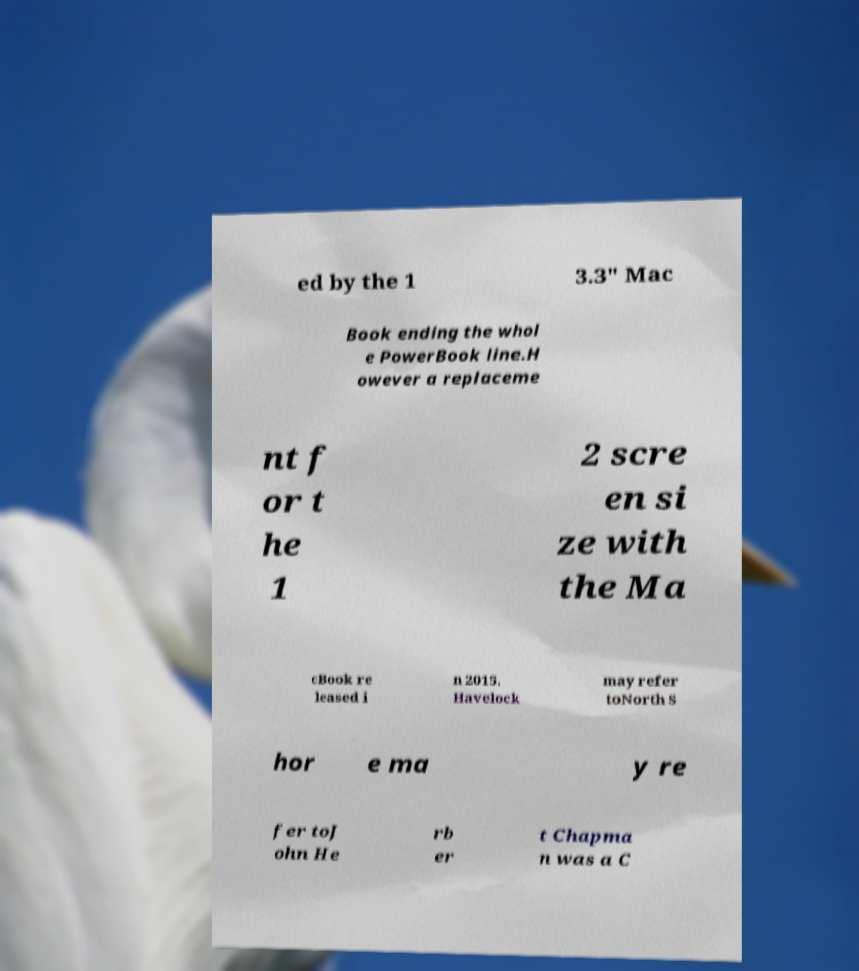Could you extract and type out the text from this image? ed by the 1 3.3" Mac Book ending the whol e PowerBook line.H owever a replaceme nt f or t he 1 2 scre en si ze with the Ma cBook re leased i n 2015. Havelock may refer toNorth S hor e ma y re fer toJ ohn He rb er t Chapma n was a C 